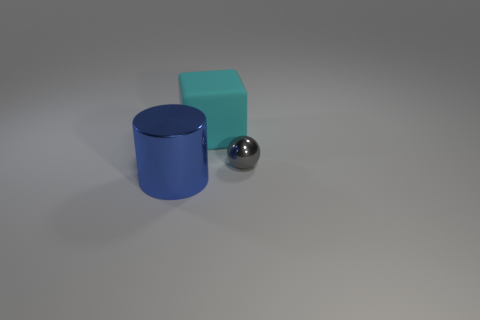Is there anything else that has the same size as the gray metal object?
Offer a very short reply. No. How many large metallic cylinders have the same color as the sphere?
Make the answer very short. 0. The big cylinder that is the same material as the small thing is what color?
Keep it short and to the point. Blue. Are there any red rubber spheres of the same size as the blue object?
Offer a very short reply. No. Are there more objects in front of the cyan matte block than large blue things in front of the shiny cylinder?
Keep it short and to the point. Yes. Do the big object that is in front of the cyan block and the big object that is behind the blue object have the same material?
Your response must be concise. No. What shape is the cyan thing that is the same size as the blue shiny object?
Your answer should be very brief. Cube. There is a shiny sphere; are there any big objects in front of it?
Provide a short and direct response. Yes. What is the material of the object that is on the left side of the gray sphere and to the right of the blue cylinder?
Offer a terse response. Rubber. Does the big object behind the blue object have the same material as the blue thing?
Offer a terse response. No. 